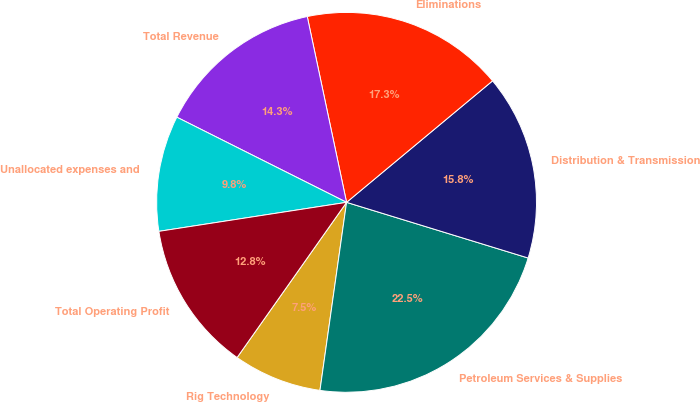Convert chart to OTSL. <chart><loc_0><loc_0><loc_500><loc_500><pie_chart><fcel>Rig Technology<fcel>Petroleum Services & Supplies<fcel>Distribution & Transmission<fcel>Eliminations<fcel>Total Revenue<fcel>Unallocated expenses and<fcel>Total Operating Profit<nl><fcel>7.54%<fcel>22.5%<fcel>15.78%<fcel>17.27%<fcel>14.28%<fcel>9.84%<fcel>12.78%<nl></chart> 